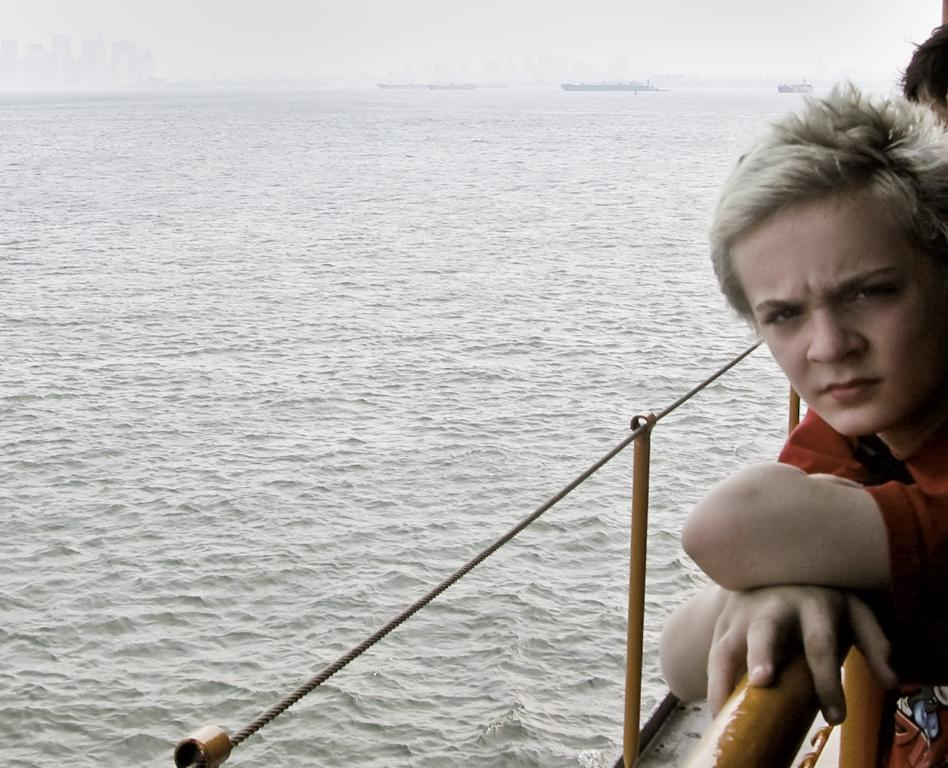What is the main subject of the image? The main subject of the image is a boy. What is the boy doing in the image? The boy is standing by holding the railing. What can be seen on the left side of the image? There is a water surface on the left side of the image. What type of vest is the boy wearing in the image? There is no vest visible in the image; the boy is not wearing one. Can you tell me what office the boy is working in from the image? The image does not show the boy in an office setting, so it cannot be determined from the image. 